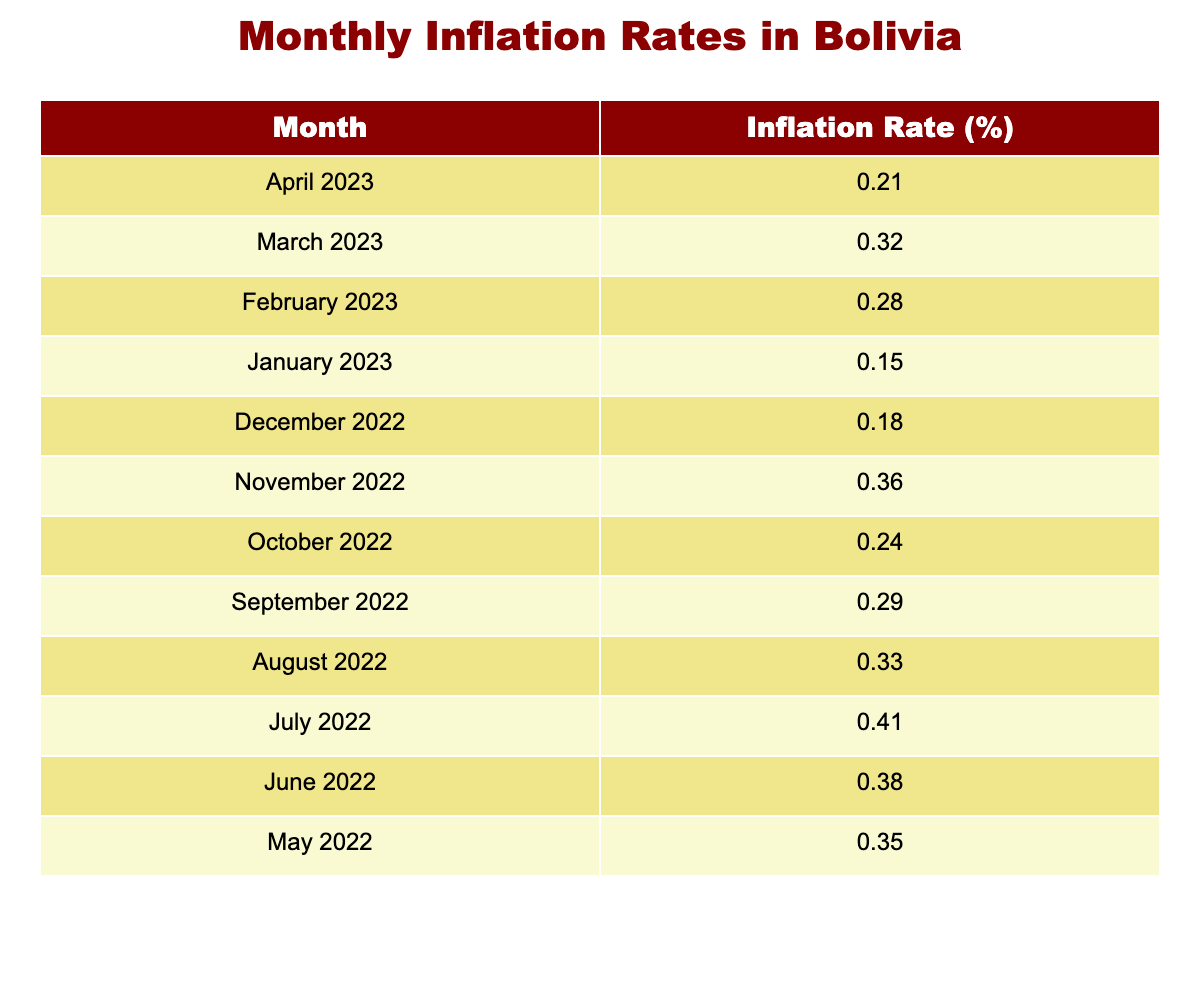What was the inflation rate in April 2023? The table shows that the inflation rate for April 2023 is listed as 0.21%.
Answer: 0.21% What was the highest inflation rate over the past year? By reviewing the inflation rates listed in the table, the highest rate appears in November 2022 at 0.36%.
Answer: 0.36% What trend can be observed from January 2023 to April 2023? The inflation rates from January to April show a general increase: 0.15% (Jan), 0.28% (Feb), 0.32% (Mar), and finally 0.21% (Apr) indicating a peak in March 2023.
Answer: Increasing until March, then a slight decrease in April What is the average inflation rate for the first quarter of 2023? The inflation rates for the first quarter are: January (0.15%), February (0.28%), and March (0.32%). The average is calculated as (0.15 + 0.28 + 0.32) / 3 = 0.25%.
Answer: 0.25% Was there any month with an inflation rate above 0.4%? Scanning through the table, the inflation rates do not exceed 0.4% in any month listed. Therefore, the answer is no.
Answer: No What is the total inflation rate from January 2023 to April 2023? Adding the inflation rates for these months gives: 0.15% (Jan) + 0.28% (Feb) + 0.32% (Mar) + 0.21% (Apr) = 1.06%.
Answer: 1.06% Which month recorded a lower inflation rate, December 2022 or February 2023? December 2022 shows an inflation rate of 0.18% while February 2023 shows 0.28%. Comparatively, December is lower than February.
Answer: December 2022 How does the inflation rate of March 2023 compare to that of November 2022? March 2023 has an inflation rate of 0.32% compared to November 2022's rate of 0.36%. November 2022 is higher than March 2023.
Answer: November 2022 is higher What month had the highest inflation rate prior to April 2023? Looking at the data, the highest inflation rate before April 2023 was in November 2022 at 0.36%.
Answer: November 2022 If the inflation rate continues to decrease as observed from March to April 2023, what would be a likely expectation for May 2023? Given the trend of decreasing inflation from March to April, one might expect that May 2023 could have an inflation rate lower than 0.21%, assuming similar trends continue.
Answer: Likely lower than 0.21% 